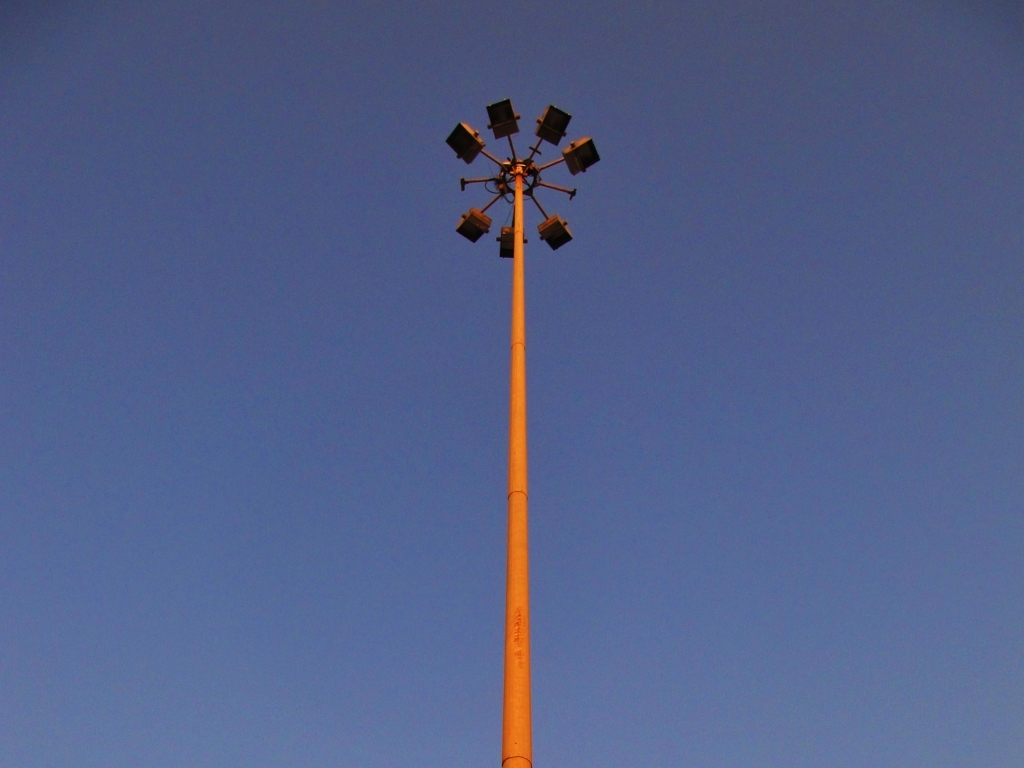What time of day does the sky suggest it is in this image? The deepening blue hue of the sky, lacking any bright sunlight or a visible sunset, suggests it is either dawn or dusk, with the latter being more probable based on the color gradient. 